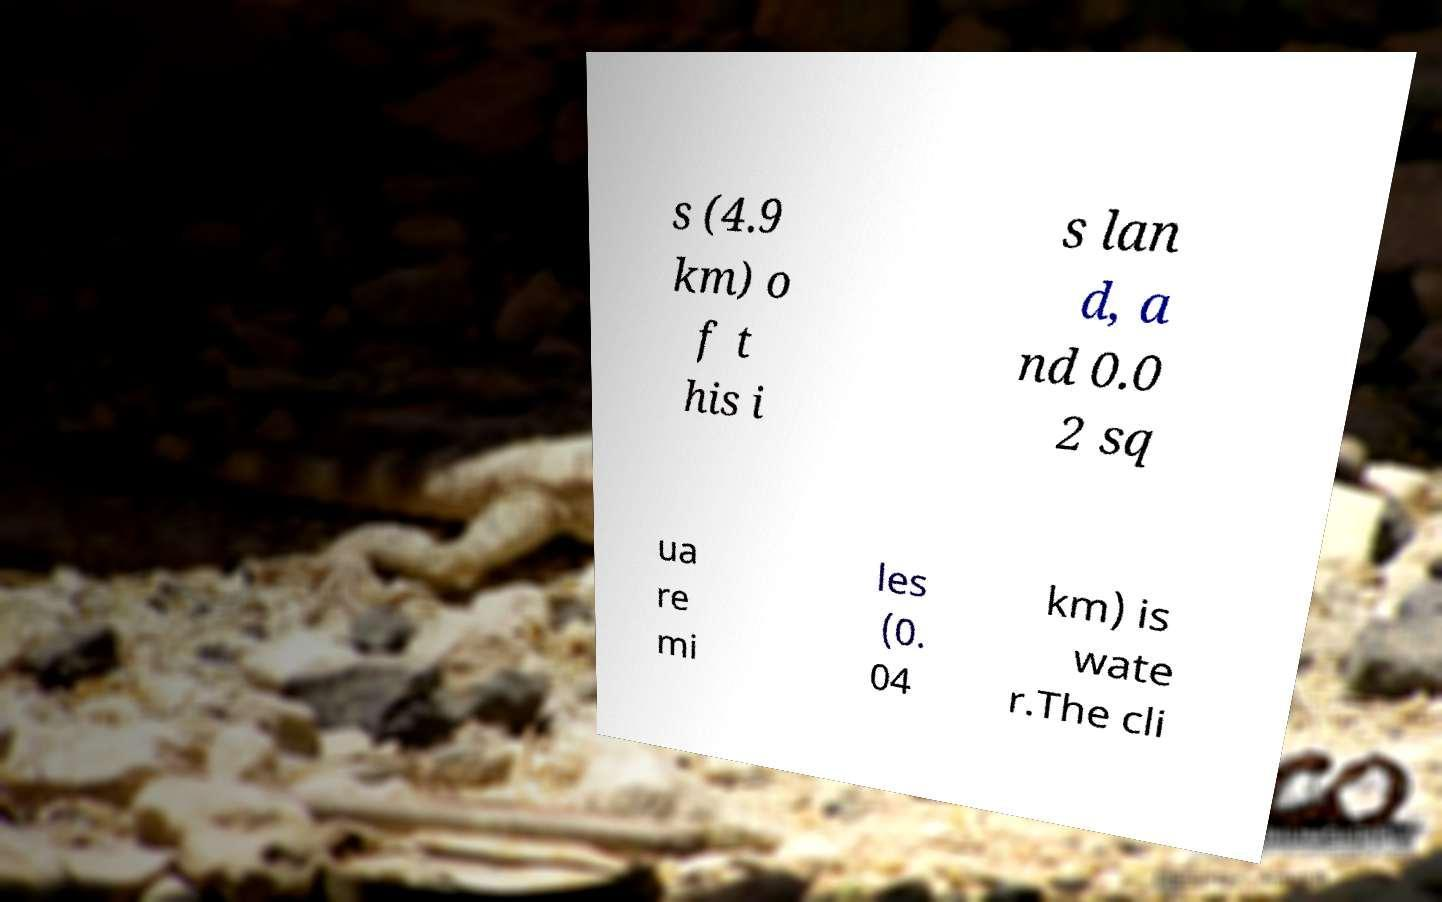Can you read and provide the text displayed in the image?This photo seems to have some interesting text. Can you extract and type it out for me? s (4.9 km) o f t his i s lan d, a nd 0.0 2 sq ua re mi les (0. 04 km) is wate r.The cli 